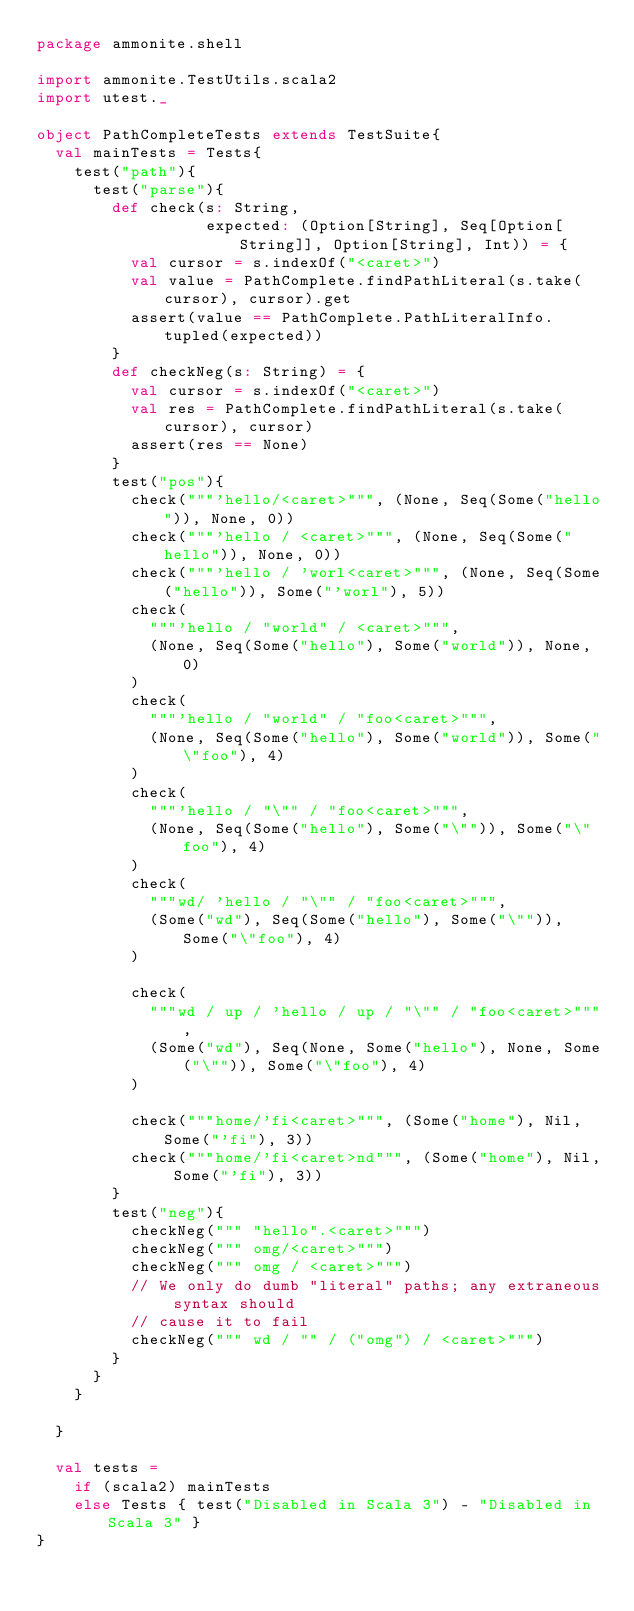<code> <loc_0><loc_0><loc_500><loc_500><_Scala_>package ammonite.shell

import ammonite.TestUtils.scala2
import utest._

object PathCompleteTests extends TestSuite{
  val mainTests = Tests{
    test("path"){
      test("parse"){
        def check(s: String,
                  expected: (Option[String], Seq[Option[String]], Option[String], Int)) = {
          val cursor = s.indexOf("<caret>")
          val value = PathComplete.findPathLiteral(s.take(cursor), cursor).get
          assert(value == PathComplete.PathLiteralInfo.tupled(expected))
        }
        def checkNeg(s: String) = {
          val cursor = s.indexOf("<caret>")
          val res = PathComplete.findPathLiteral(s.take(cursor), cursor)
          assert(res == None)
        }
        test("pos"){
          check("""'hello/<caret>""", (None, Seq(Some("hello")), None, 0))
          check("""'hello / <caret>""", (None, Seq(Some("hello")), None, 0))
          check("""'hello / 'worl<caret>""", (None, Seq(Some("hello")), Some("'worl"), 5))
          check(
            """'hello / "world" / <caret>""",
            (None, Seq(Some("hello"), Some("world")), None, 0)
          )
          check(
            """'hello / "world" / "foo<caret>""",
            (None, Seq(Some("hello"), Some("world")), Some("\"foo"), 4)
          )
          check(
            """'hello / "\"" / "foo<caret>""",
            (None, Seq(Some("hello"), Some("\"")), Some("\"foo"), 4)
          )
          check(
            """wd/ 'hello / "\"" / "foo<caret>""",
            (Some("wd"), Seq(Some("hello"), Some("\"")), Some("\"foo"), 4)
          )

          check(
            """wd / up / 'hello / up / "\"" / "foo<caret>""",
            (Some("wd"), Seq(None, Some("hello"), None, Some("\"")), Some("\"foo"), 4)
          )

          check("""home/'fi<caret>""", (Some("home"), Nil, Some("'fi"), 3))
          check("""home/'fi<caret>nd""", (Some("home"), Nil, Some("'fi"), 3))
        }
        test("neg"){
          checkNeg(""" "hello".<caret>""")
          checkNeg(""" omg/<caret>""")
          checkNeg(""" omg / <caret>""")
          // We only do dumb "literal" paths; any extraneous syntax should
          // cause it to fail
          checkNeg(""" wd / "" / ("omg") / <caret>""")
        }
      }
    }

  }

  val tests =
    if (scala2) mainTests
    else Tests { test("Disabled in Scala 3") - "Disabled in Scala 3" }
}
</code> 